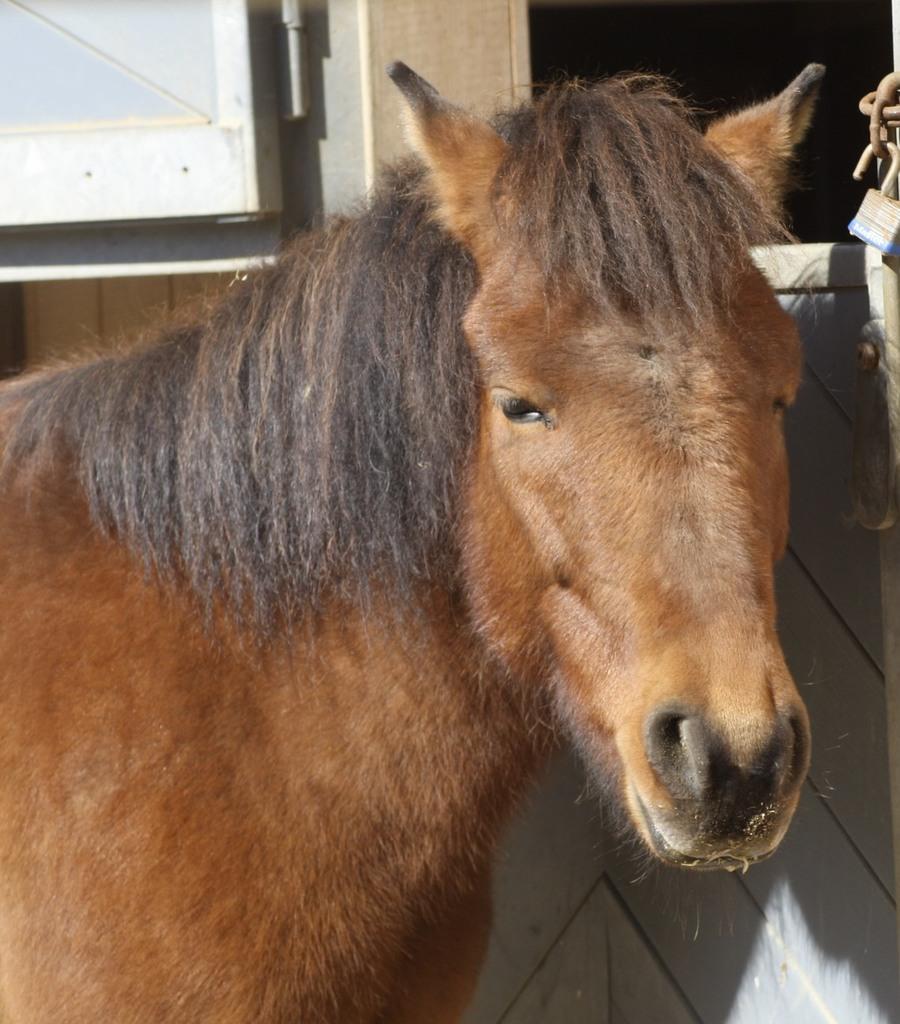Please provide a concise description of this image. In this picture, we see a brown horse. It has the black mane. Beside that, we see a wooden wall and a lock. In the background, we see a wall and a window. This picture might be clicked in the stable. 